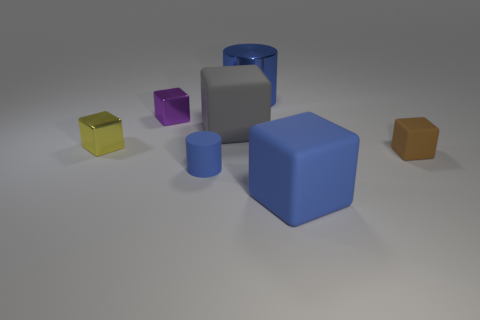Subtract 2 blocks. How many blocks are left? 3 Subtract all brown matte blocks. How many blocks are left? 4 Subtract all gray blocks. How many blocks are left? 4 Subtract all purple blocks. Subtract all red cylinders. How many blocks are left? 4 Add 2 large cylinders. How many objects exist? 9 Subtract all cylinders. How many objects are left? 5 Subtract all shiny objects. Subtract all tiny matte cylinders. How many objects are left? 3 Add 2 small yellow blocks. How many small yellow blocks are left? 3 Add 4 small gray shiny cubes. How many small gray shiny cubes exist? 4 Subtract 0 cyan cylinders. How many objects are left? 7 